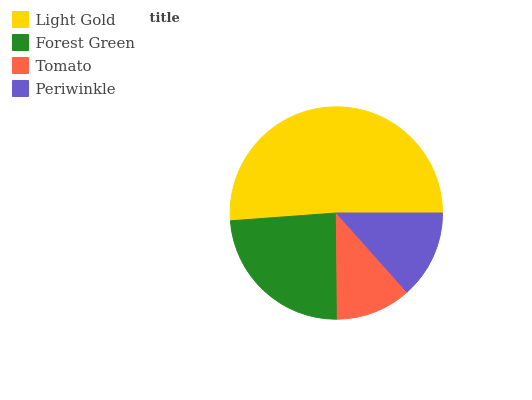Is Tomato the minimum?
Answer yes or no. Yes. Is Light Gold the maximum?
Answer yes or no. Yes. Is Forest Green the minimum?
Answer yes or no. No. Is Forest Green the maximum?
Answer yes or no. No. Is Light Gold greater than Forest Green?
Answer yes or no. Yes. Is Forest Green less than Light Gold?
Answer yes or no. Yes. Is Forest Green greater than Light Gold?
Answer yes or no. No. Is Light Gold less than Forest Green?
Answer yes or no. No. Is Forest Green the high median?
Answer yes or no. Yes. Is Periwinkle the low median?
Answer yes or no. Yes. Is Light Gold the high median?
Answer yes or no. No. Is Forest Green the low median?
Answer yes or no. No. 